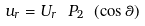<formula> <loc_0><loc_0><loc_500><loc_500>u _ { r } = U _ { r } \ P _ { 2 } \ ( \cos \theta )</formula> 